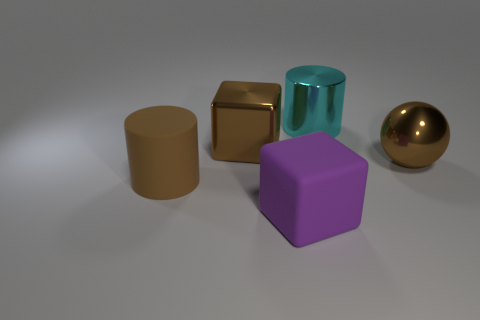Add 2 brown spheres. How many objects exist? 7 Subtract all cylinders. How many objects are left? 3 Add 4 big cubes. How many big cubes exist? 6 Subtract 0 green cubes. How many objects are left? 5 Subtract all big matte blocks. Subtract all big yellow cylinders. How many objects are left? 4 Add 1 large matte cubes. How many large matte cubes are left? 2 